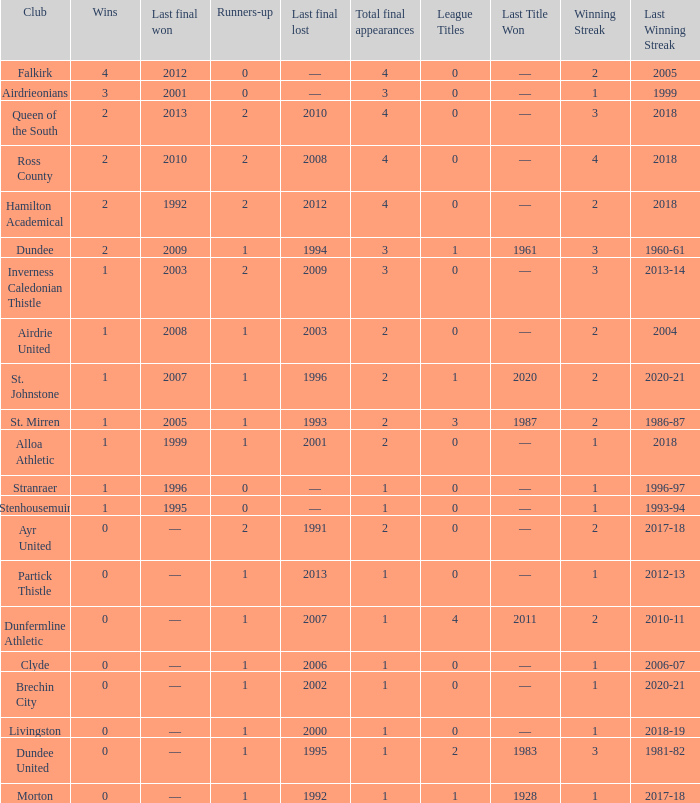How manywins for dunfermline athletic that has a total final appearances less than 2? 0.0. 